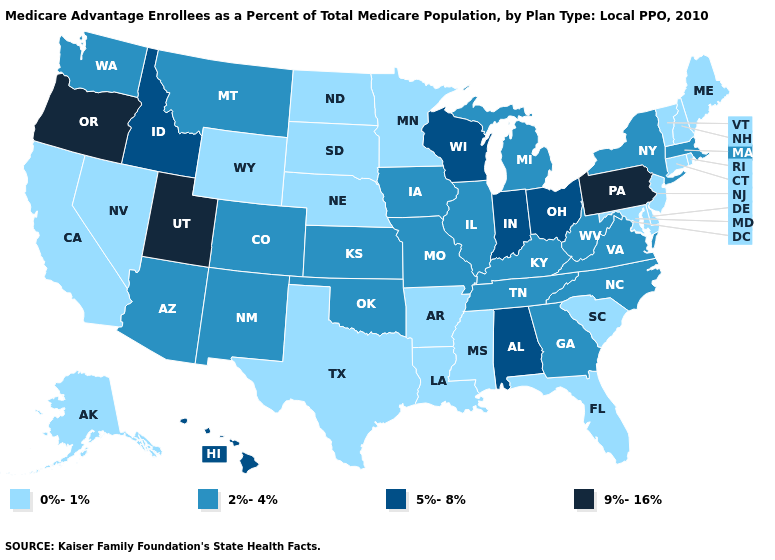Name the states that have a value in the range 2%-4%?
Answer briefly. Arizona, Colorado, Georgia, Iowa, Illinois, Kansas, Kentucky, Massachusetts, Michigan, Missouri, Montana, North Carolina, New Mexico, New York, Oklahoma, Tennessee, Virginia, Washington, West Virginia. What is the lowest value in states that border Washington?
Answer briefly. 5%-8%. Which states have the highest value in the USA?
Give a very brief answer. Oregon, Pennsylvania, Utah. Is the legend a continuous bar?
Answer briefly. No. Among the states that border North Carolina , does Virginia have the highest value?
Short answer required. Yes. Is the legend a continuous bar?
Give a very brief answer. No. What is the highest value in states that border Oregon?
Quick response, please. 5%-8%. What is the lowest value in the USA?
Short answer required. 0%-1%. Which states have the lowest value in the Northeast?
Be succinct. Connecticut, Maine, New Hampshire, New Jersey, Rhode Island, Vermont. How many symbols are there in the legend?
Keep it brief. 4. What is the lowest value in the USA?
Give a very brief answer. 0%-1%. Among the states that border Minnesota , does Wisconsin have the highest value?
Give a very brief answer. Yes. Name the states that have a value in the range 0%-1%?
Concise answer only. Alaska, Arkansas, California, Connecticut, Delaware, Florida, Louisiana, Maryland, Maine, Minnesota, Mississippi, North Dakota, Nebraska, New Hampshire, New Jersey, Nevada, Rhode Island, South Carolina, South Dakota, Texas, Vermont, Wyoming. What is the lowest value in the USA?
Concise answer only. 0%-1%. 